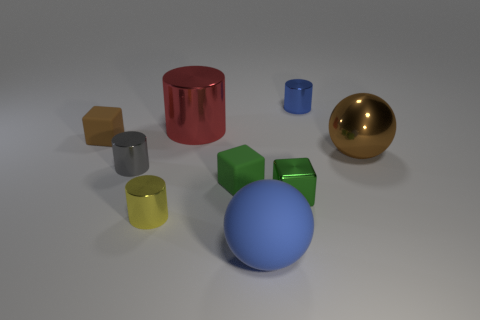Add 1 brown rubber things. How many objects exist? 10 Subtract all cylinders. How many objects are left? 5 Add 1 small cylinders. How many small cylinders are left? 4 Add 6 brown rubber spheres. How many brown rubber spheres exist? 6 Subtract 1 red cylinders. How many objects are left? 8 Subtract all big brown metallic balls. Subtract all small yellow metallic cylinders. How many objects are left? 7 